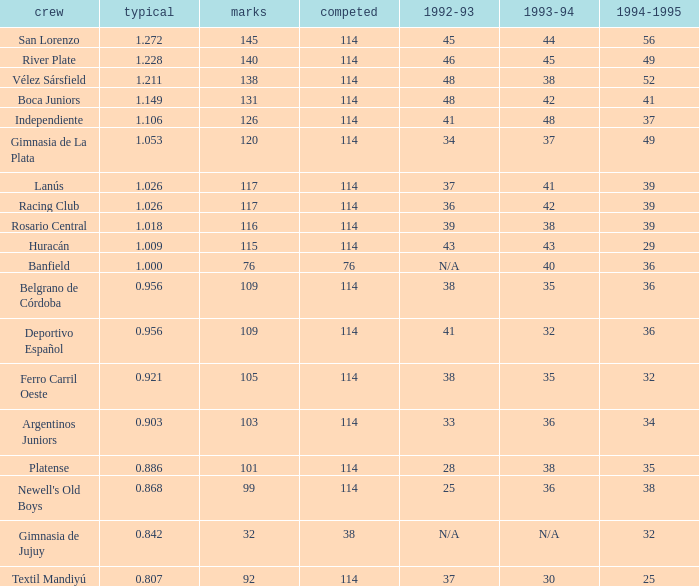Name the team for 1993-94 for 32 Deportivo Español. Parse the full table. {'header': ['crew', 'typical', 'marks', 'competed', '1992-93', '1993-94', '1994-1995'], 'rows': [['San Lorenzo', '1.272', '145', '114', '45', '44', '56'], ['River Plate', '1.228', '140', '114', '46', '45', '49'], ['Vélez Sársfield', '1.211', '138', '114', '48', '38', '52'], ['Boca Juniors', '1.149', '131', '114', '48', '42', '41'], ['Independiente', '1.106', '126', '114', '41', '48', '37'], ['Gimnasia de La Plata', '1.053', '120', '114', '34', '37', '49'], ['Lanús', '1.026', '117', '114', '37', '41', '39'], ['Racing Club', '1.026', '117', '114', '36', '42', '39'], ['Rosario Central', '1.018', '116', '114', '39', '38', '39'], ['Huracán', '1.009', '115', '114', '43', '43', '29'], ['Banfield', '1.000', '76', '76', 'N/A', '40', '36'], ['Belgrano de Córdoba', '0.956', '109', '114', '38', '35', '36'], ['Deportivo Español', '0.956', '109', '114', '41', '32', '36'], ['Ferro Carril Oeste', '0.921', '105', '114', '38', '35', '32'], ['Argentinos Juniors', '0.903', '103', '114', '33', '36', '34'], ['Platense', '0.886', '101', '114', '28', '38', '35'], ["Newell's Old Boys", '0.868', '99', '114', '25', '36', '38'], ['Gimnasia de Jujuy', '0.842', '32', '38', 'N/A', 'N/A', '32'], ['Textil Mandiyú', '0.807', '92', '114', '37', '30', '25']]} 